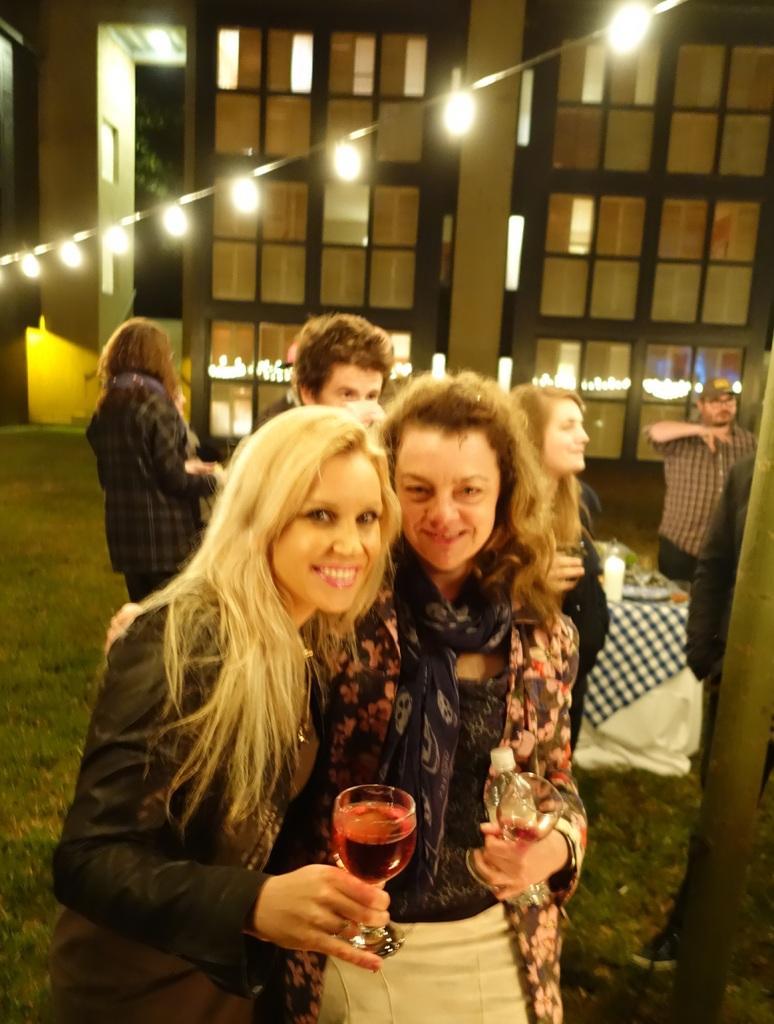Could you give a brief overview of what you see in this image? In this image, we can see people standing and holding glasses in their hands, which are containing liquid and in the background, there are buildings, lights and we can see a table and some objects are placed on it. At the bottom, there is ground. 